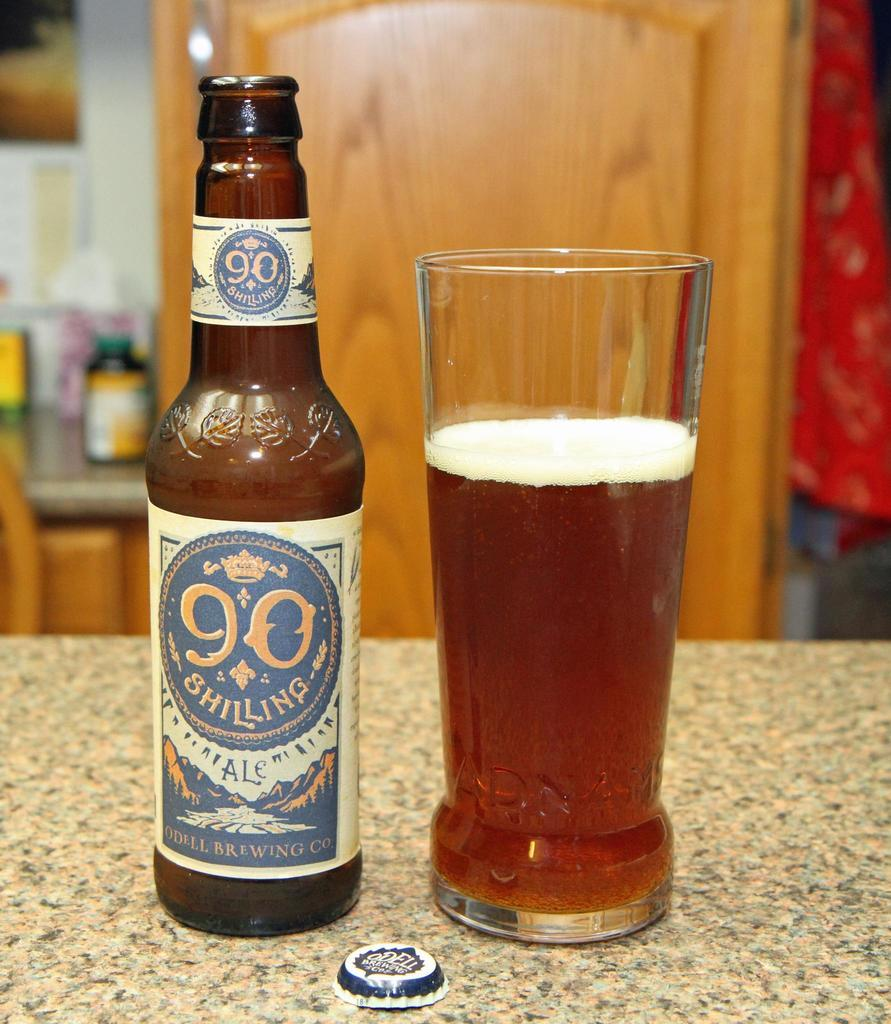<image>
Share a concise interpretation of the image provided. A glass of 90 Shilling beer is great to drink on a warm day. 